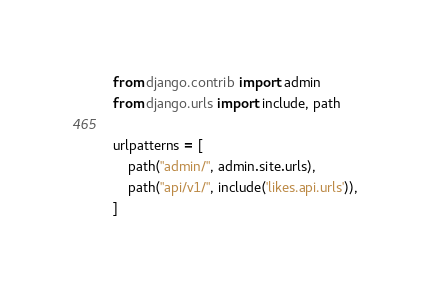<code> <loc_0><loc_0><loc_500><loc_500><_Python_>from django.contrib import admin
from django.urls import include, path

urlpatterns = [
    path("admin/", admin.site.urls),
    path("api/v1/", include('likes.api.urls')),
]
</code> 